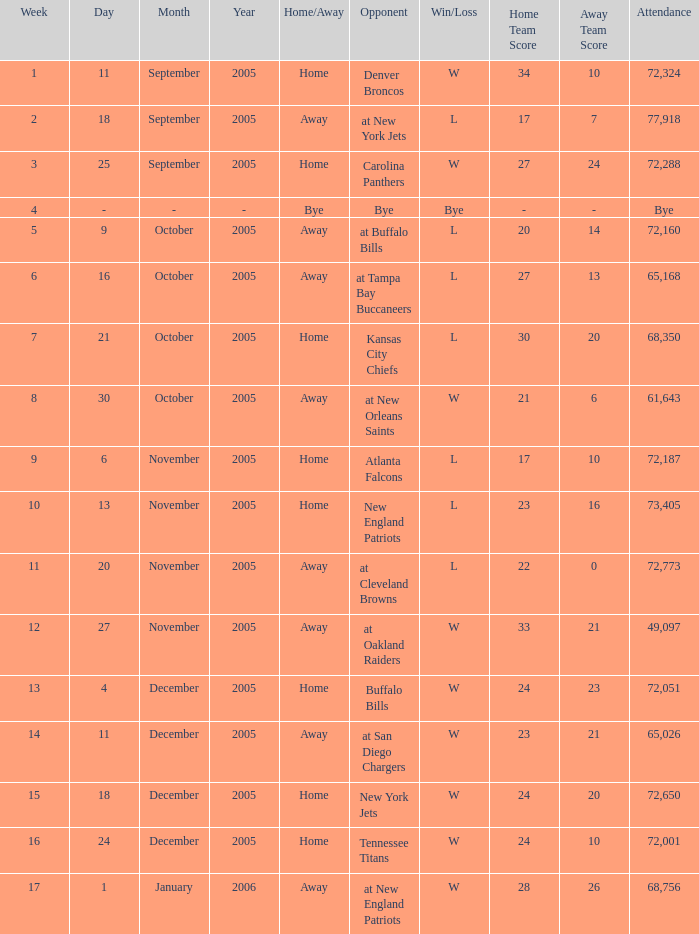On what Date was the Attendance 73,405? November 13, 2005. 